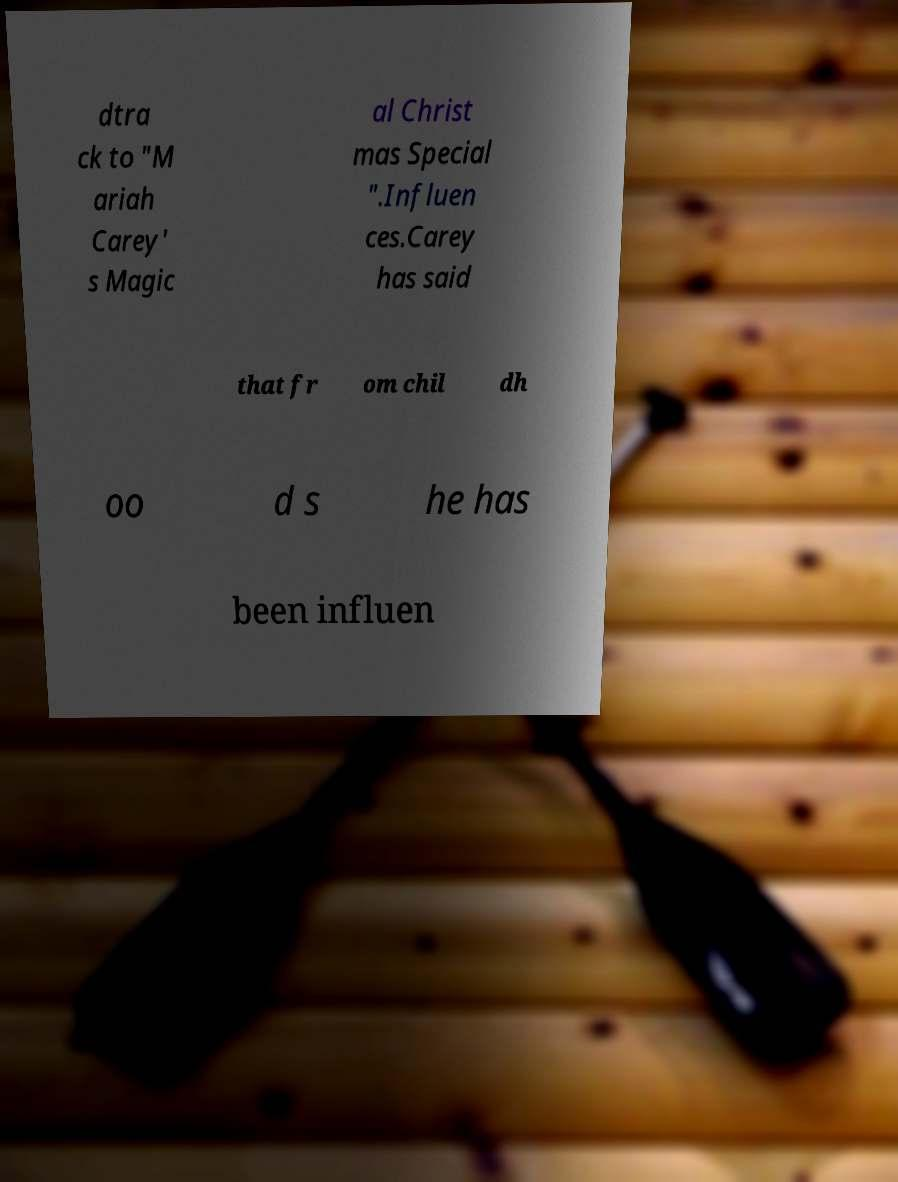I need the written content from this picture converted into text. Can you do that? dtra ck to "M ariah Carey' s Magic al Christ mas Special ".Influen ces.Carey has said that fr om chil dh oo d s he has been influen 